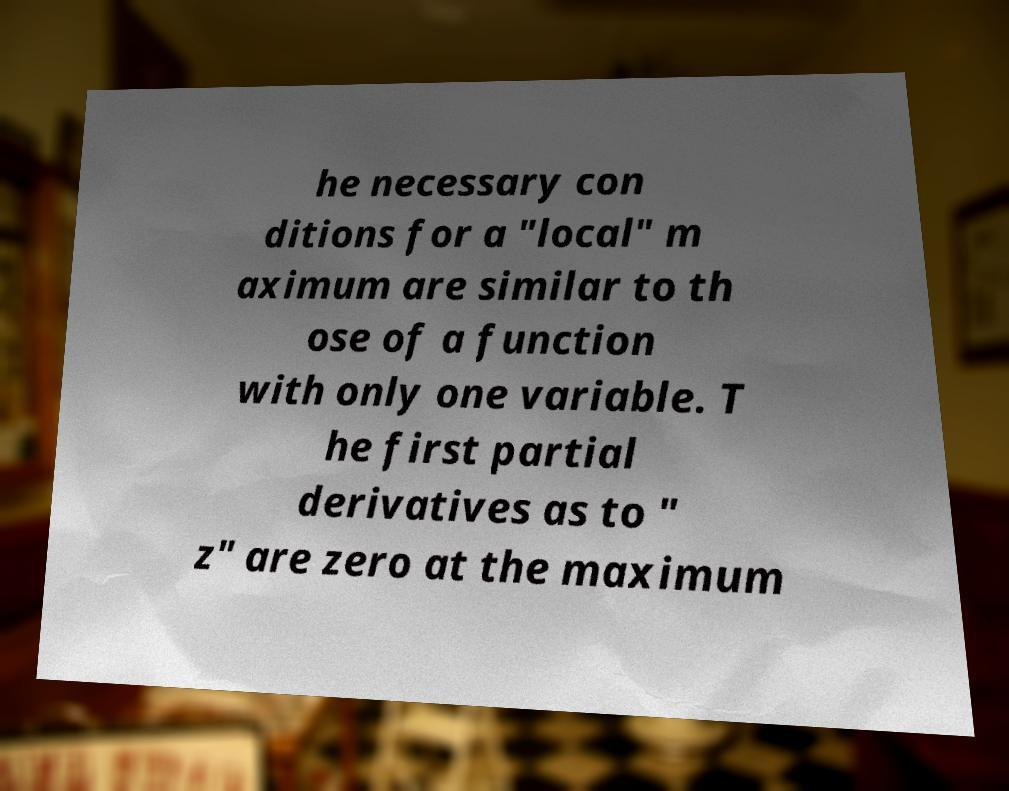Could you extract and type out the text from this image? he necessary con ditions for a "local" m aximum are similar to th ose of a function with only one variable. T he first partial derivatives as to " z" are zero at the maximum 